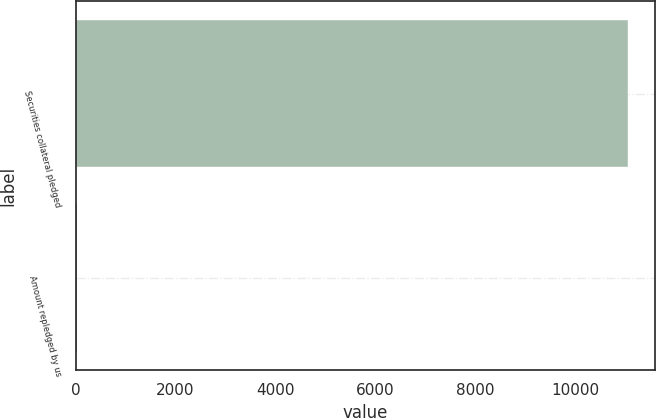<chart> <loc_0><loc_0><loc_500><loc_500><bar_chart><fcel>Securities collateral pledged<fcel>Amount repledged by us<nl><fcel>11039<fcel>33<nl></chart> 